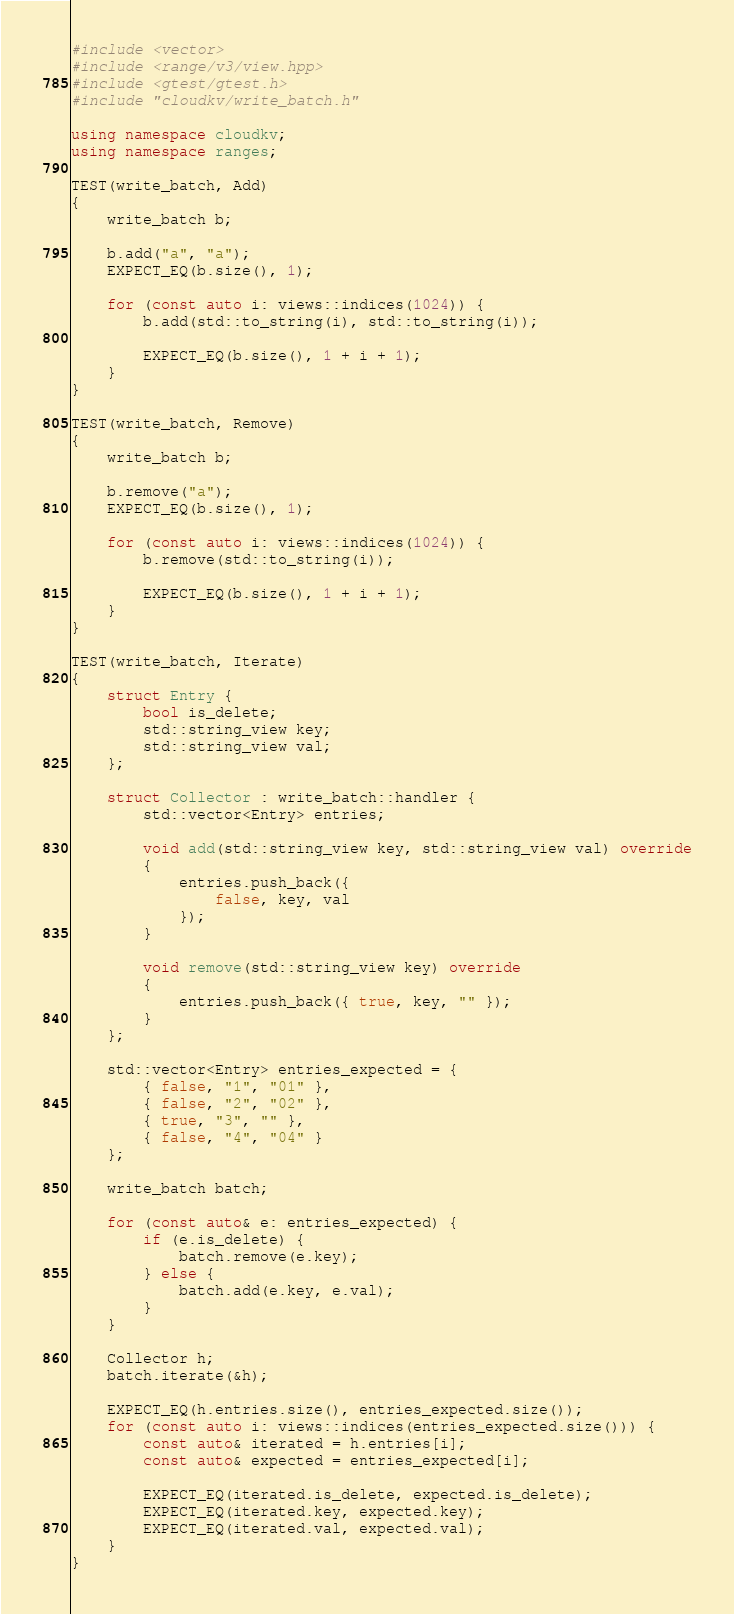Convert code to text. <code><loc_0><loc_0><loc_500><loc_500><_C++_>#include <vector>
#include <range/v3/view.hpp>
#include <gtest/gtest.h>
#include "cloudkv/write_batch.h"

using namespace cloudkv;
using namespace ranges;

TEST(write_batch, Add)
{
    write_batch b;

    b.add("a", "a");
    EXPECT_EQ(b.size(), 1);

    for (const auto i: views::indices(1024)) {
        b.add(std::to_string(i), std::to_string(i));

        EXPECT_EQ(b.size(), 1 + i + 1);
    }
}

TEST(write_batch, Remove)
{
    write_batch b;

    b.remove("a");
    EXPECT_EQ(b.size(), 1);

    for (const auto i: views::indices(1024)) {
        b.remove(std::to_string(i));

        EXPECT_EQ(b.size(), 1 + i + 1);
    }
}

TEST(write_batch, Iterate)
{
    struct Entry {
        bool is_delete;
        std::string_view key;
        std::string_view val;
    };

    struct Collector : write_batch::handler {
        std::vector<Entry> entries;

        void add(std::string_view key, std::string_view val) override
        {
            entries.push_back({
                false, key, val
            });
        }

        void remove(std::string_view key) override
        {
            entries.push_back({ true, key, "" });
        }
    };

    std::vector<Entry> entries_expected = {
        { false, "1", "01" },
        { false, "2", "02" },
        { true, "3", "" },
        { false, "4", "04" }
    };

    write_batch batch;

    for (const auto& e: entries_expected) {
        if (e.is_delete) {
            batch.remove(e.key);
        } else {
            batch.add(e.key, e.val);
        }
    }

    Collector h;
    batch.iterate(&h);

    EXPECT_EQ(h.entries.size(), entries_expected.size());
    for (const auto i: views::indices(entries_expected.size())) {
        const auto& iterated = h.entries[i];
        const auto& expected = entries_expected[i];

        EXPECT_EQ(iterated.is_delete, expected.is_delete);
        EXPECT_EQ(iterated.key, expected.key);
        EXPECT_EQ(iterated.val, expected.val);
    }
}</code> 